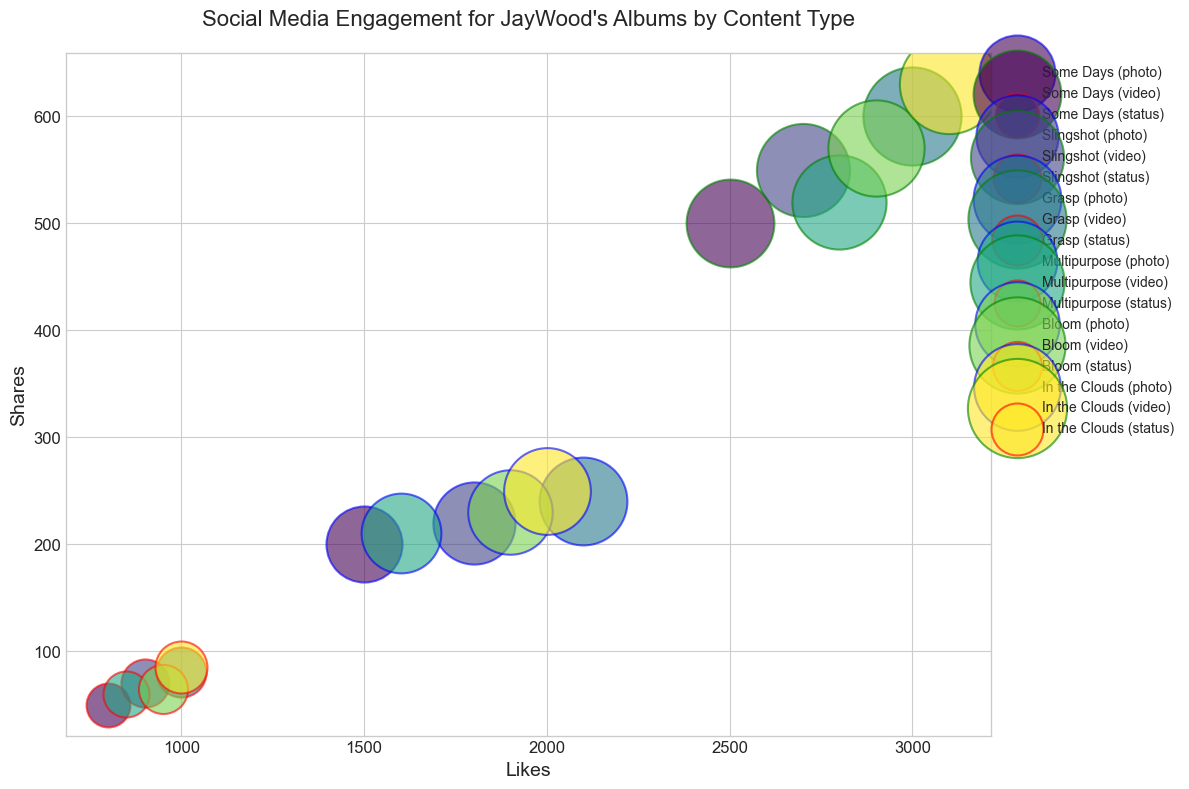Which album has the highest number of shares for photos? To find the album with the highest number of shares for photos, look for photo content types and compare the share counts. "In the Clouds" has 250 shares, which is the highest among all albums' photo content types.
Answer: "In the Clouds" Which content type has more comments for the album "Some Days," photos or videos? Compare the comments for photos and videos within the "Some Days" album. Photos have 300 comments, while videos have 400 comments. Videos have more comments.
Answer: videos Which album and content type combination has the maximum number of likes? Check all album and content type combinations for the one with the highest likes. The "In the Clouds" album's video content type has 3100 likes, which is the maximum.
Answer: "In the Clouds" (video) Compare the engagement for status updates between the "Grasp" and "Multipurpose" albums. Which has higher values? Compare the likes, shares, and comments for status updates in "Grasp" and "Multipurpose." "Grasp" has 1000 likes, 80 shares, and 130 comments, while "Multipurpose" has 850 likes, 60 shares, and 110 comments. "Grasp" has higher values in all three metrics.
Answer: "Grasp" What is the average number of likes for the album "Bloom" across all content types? Sum the likes for "photo," "video," and "status" content types under the "Bloom" album and divide by the number of content types. The total likes are 1900 (photo) + 2900 (video) + 950 (status) = 5750. The average is 5750 / 3 ≈ 1917.
Answer: 1917 Which album has the smallest bubble size for video content? Bubble size corresponds to comments, so look for the smallest comments value among videos. "Some Days" has 400 comments for video, which is the smallest.
Answer: "Some Days" Does "Slingshot" have a higher average number of shares for photos or videos? Calculate the average number of shares for photos and videos in "Slingshot." Photos have 220 shares, videos have 550 shares. Videos have a higher number.
Answer: videos What are the total shares for "Multipurpose" combining all content types? Sum the shares of all content types under the "Multipurpose" album. The total shares are 210 (photo) + 520 (video) + 60 (status) = 790.
Answer: 790 